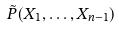Convert formula to latex. <formula><loc_0><loc_0><loc_500><loc_500>\tilde { P } ( X _ { 1 } , \dots , X _ { n - 1 } )</formula> 